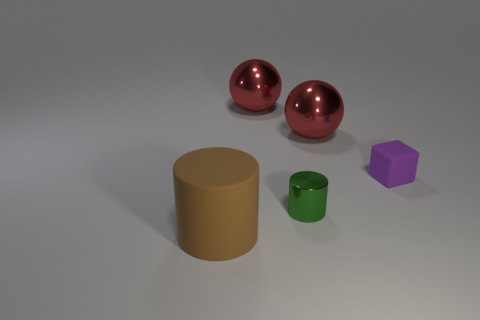Add 4 purple matte objects. How many objects exist? 9 Subtract all spheres. How many objects are left? 3 Subtract all rubber cylinders. Subtract all big metal objects. How many objects are left? 2 Add 1 small metal cylinders. How many small metal cylinders are left? 2 Add 4 small cyan cylinders. How many small cyan cylinders exist? 4 Subtract 0 gray balls. How many objects are left? 5 